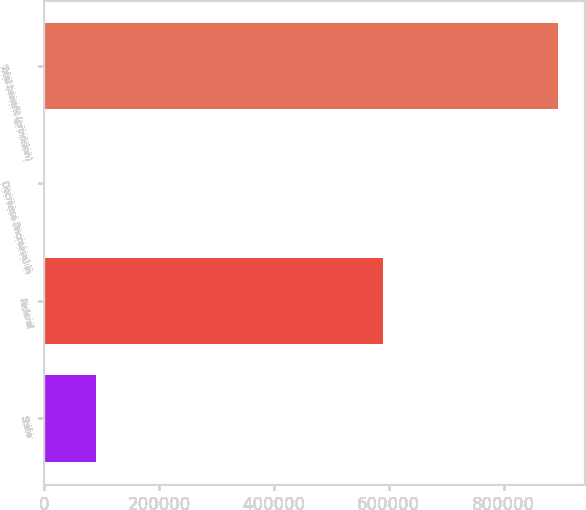<chart> <loc_0><loc_0><loc_500><loc_500><bar_chart><fcel>State<fcel>Federal<fcel>Decrease (increase) in<fcel>Total benefit (provision)<nl><fcel>91082.8<fcel>590618<fcel>1758<fcel>895006<nl></chart> 